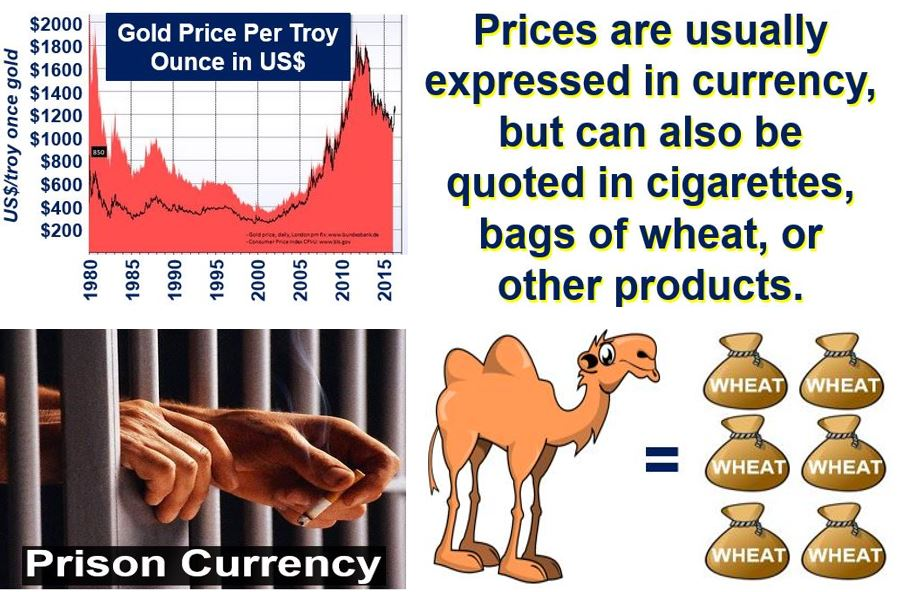What alternative commodities mentioned in the image might act as currency in a prison environment? In the image, it mentions that prices can be expressed using various commodities such as cigarettes and bags of wheat. In a prison environment, these items can serve as currency due to their intrinsic value and demand among inmates. Cigarettes are particularly highlighted as a common alternative currency in prisons because of their high desirability and ease of trading. Wheat could also potentially serve in this role if it is a demanded and scarce resource. 